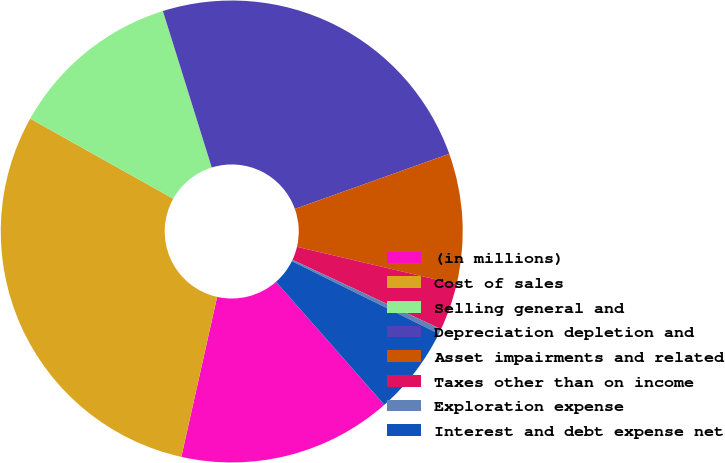<chart> <loc_0><loc_0><loc_500><loc_500><pie_chart><fcel>(in millions)<fcel>Cost of sales<fcel>Selling general and<fcel>Depreciation depletion and<fcel>Asset impairments and related<fcel>Taxes other than on income<fcel>Exploration expense<fcel>Interest and debt expense net<nl><fcel>14.99%<fcel>29.62%<fcel>12.06%<fcel>24.36%<fcel>9.13%<fcel>3.28%<fcel>0.35%<fcel>6.21%<nl></chart> 